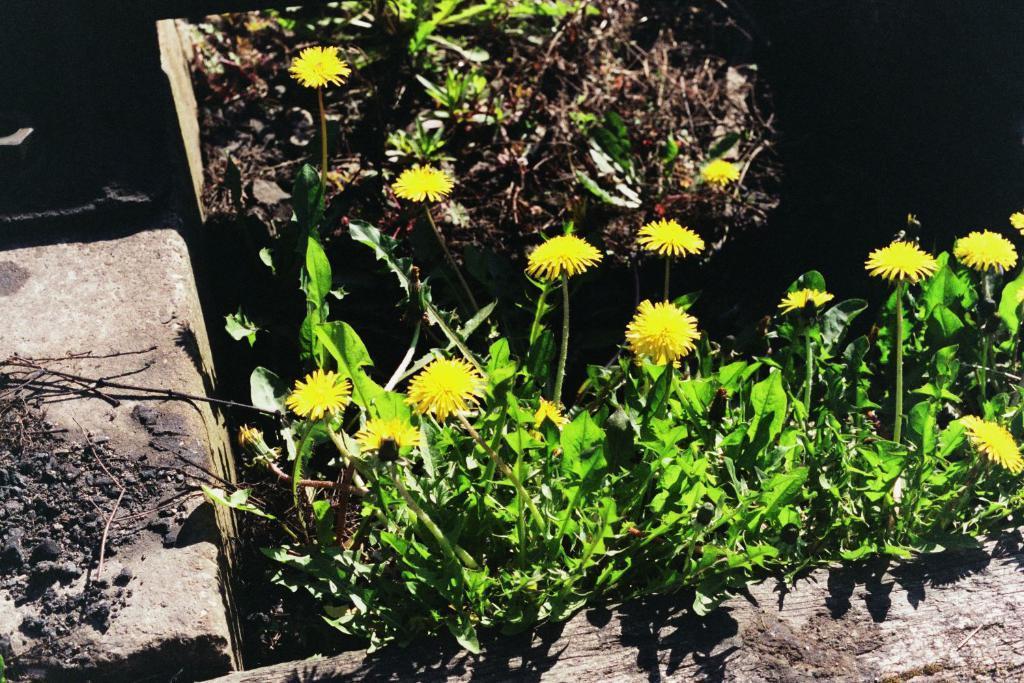How would you summarize this image in a sentence or two? There are yellow color flowers on plants. On the right side there is a slab. On that there are some items. In the back there are plants and some other things. 